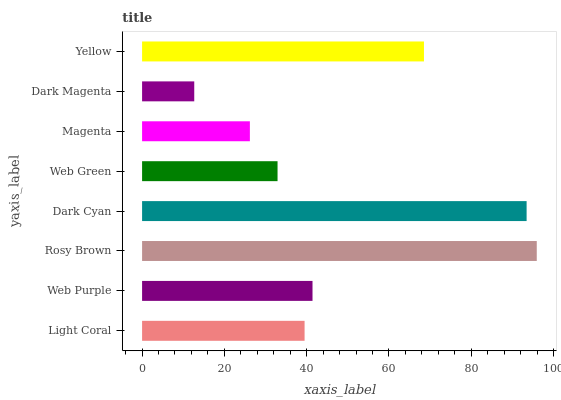Is Dark Magenta the minimum?
Answer yes or no. Yes. Is Rosy Brown the maximum?
Answer yes or no. Yes. Is Web Purple the minimum?
Answer yes or no. No. Is Web Purple the maximum?
Answer yes or no. No. Is Web Purple greater than Light Coral?
Answer yes or no. Yes. Is Light Coral less than Web Purple?
Answer yes or no. Yes. Is Light Coral greater than Web Purple?
Answer yes or no. No. Is Web Purple less than Light Coral?
Answer yes or no. No. Is Web Purple the high median?
Answer yes or no. Yes. Is Light Coral the low median?
Answer yes or no. Yes. Is Light Coral the high median?
Answer yes or no. No. Is Magenta the low median?
Answer yes or no. No. 